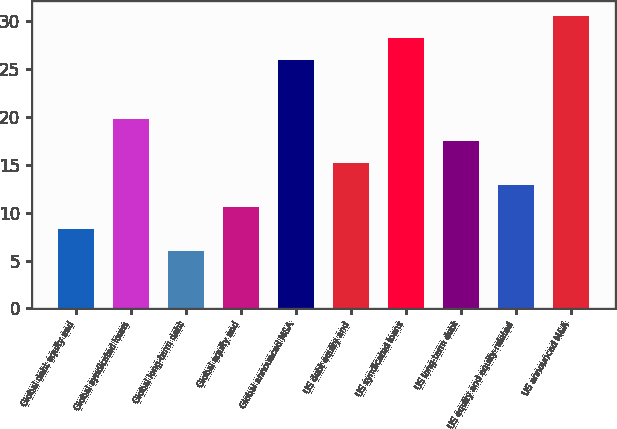Convert chart to OTSL. <chart><loc_0><loc_0><loc_500><loc_500><bar_chart><fcel>Global debt equity and<fcel>Global syndicated loans<fcel>Global long-term debt<fcel>Global equity and<fcel>Global announced M&A<fcel>US debt equity and<fcel>US syndicated loans<fcel>US long-term debt<fcel>US equity and equity-related<fcel>US announced M&A<nl><fcel>8.3<fcel>19.8<fcel>6<fcel>10.6<fcel>26<fcel>15.2<fcel>28.3<fcel>17.5<fcel>12.9<fcel>30.6<nl></chart> 